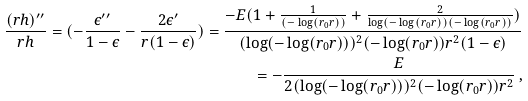Convert formula to latex. <formula><loc_0><loc_0><loc_500><loc_500>\frac { ( r h ) ^ { \prime \prime } } { r h } = ( - \frac { \epsilon ^ { \prime \prime } } { 1 - \epsilon } - \frac { 2 \epsilon ^ { \prime } } { r ( 1 - \epsilon ) } ) = \frac { - E ( 1 + \frac { 1 } { ( - \log ( r _ { 0 } r ) ) } + \frac { 2 } { \log ( - \log ( r _ { 0 } r ) ) ( - \log ( r _ { 0 } r ) ) } ) } { ( \log ( - \log ( r _ { 0 } r ) ) ) ^ { 2 } ( - \log ( r _ { 0 } r ) ) r ^ { 2 } ( 1 - \epsilon ) } \\ = - \frac { E } { 2 ( \log ( - \log ( r _ { 0 } r ) ) ) ^ { 2 } ( - \log ( r _ { 0 } r ) ) r ^ { 2 } } \, ,</formula> 